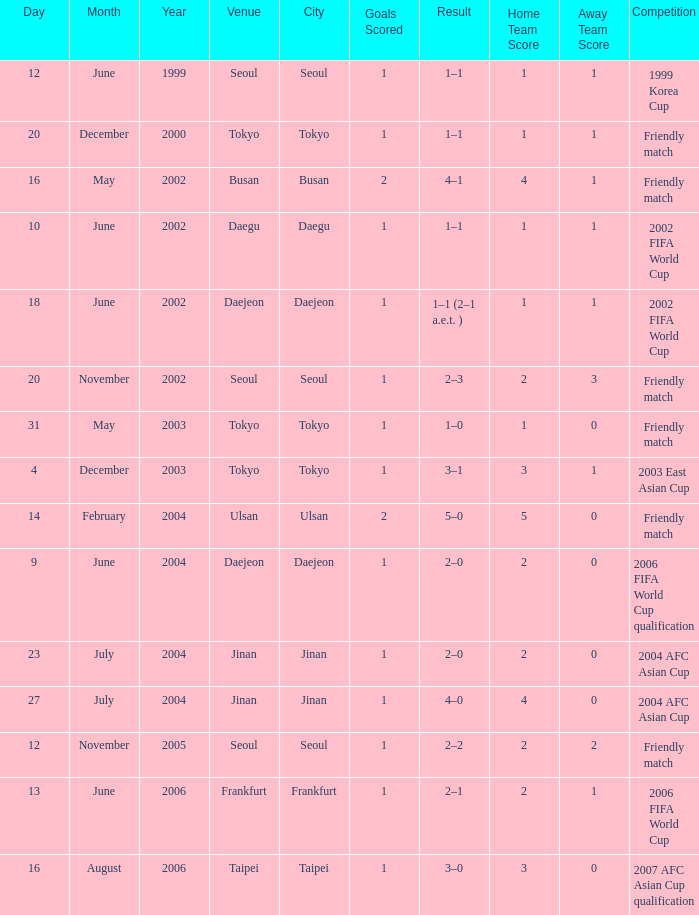What is the venue for the event on 12 November 2005? Seoul. 